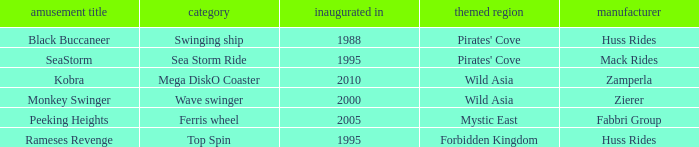What type of ride is Rameses Revenge? Top Spin. 